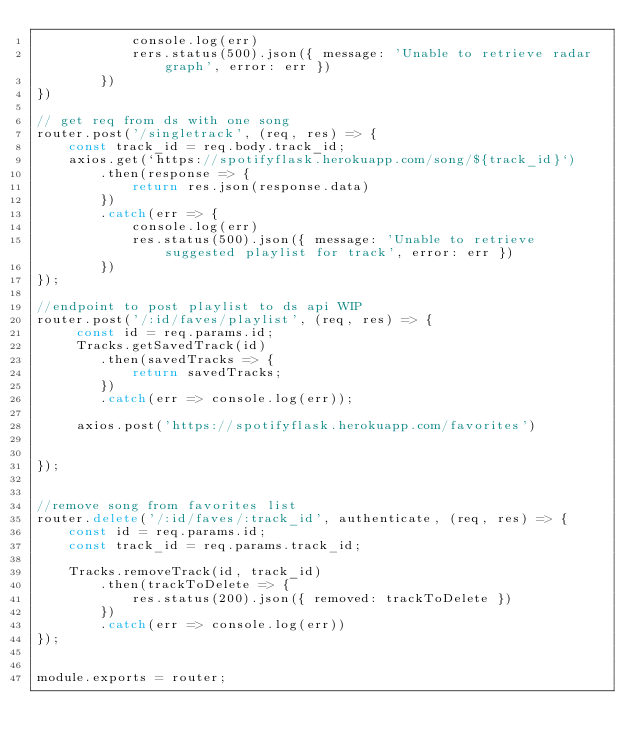Convert code to text. <code><loc_0><loc_0><loc_500><loc_500><_JavaScript_>            console.log(err)
            rers.status(500).json({ message: 'Unable to retrieve radar graph', error: err })
        })
})

// get req from ds with one song 
router.post('/singletrack', (req, res) => {
    const track_id = req.body.track_id;
    axios.get(`https://spotifyflask.herokuapp.com/song/${track_id}`)
        .then(response => {
            return res.json(response.data)
        })
        .catch(err => {
            console.log(err)
            res.status(500).json({ message: 'Unable to retrieve suggested playlist for track', error: err })
        })
});

//endpoint to post playlist to ds api WIP
router.post('/:id/faves/playlist', (req, res) => {
     const id = req.params.id;
     Tracks.getSavedTrack(id)
        .then(savedTracks => {
            return savedTracks;
        })
        .catch(err => console.log(err));

     axios.post('https://spotifyflask.herokuapp.com/favorites')
        

});


//remove song from favorites list 
router.delete('/:id/faves/:track_id', authenticate, (req, res) => {
    const id = req.params.id;
    const track_id = req.params.track_id;

    Tracks.removeTrack(id, track_id)
        .then(trackToDelete => {
            res.status(200).json({ removed: trackToDelete })
        })
        .catch(err => console.log(err))
});


module.exports = router;</code> 